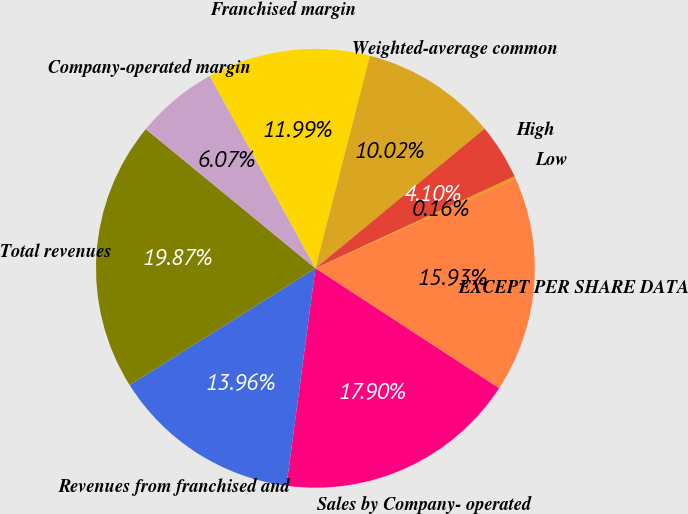<chart> <loc_0><loc_0><loc_500><loc_500><pie_chart><fcel>EXCEPT PER SHARE DATA<fcel>Sales by Company- operated<fcel>Revenues from franchised and<fcel>Total revenues<fcel>Company-operated margin<fcel>Franchised margin<fcel>Weighted-average common<fcel>High<fcel>Low<nl><fcel>15.93%<fcel>17.9%<fcel>13.96%<fcel>19.87%<fcel>6.07%<fcel>11.99%<fcel>10.02%<fcel>4.1%<fcel>0.16%<nl></chart> 